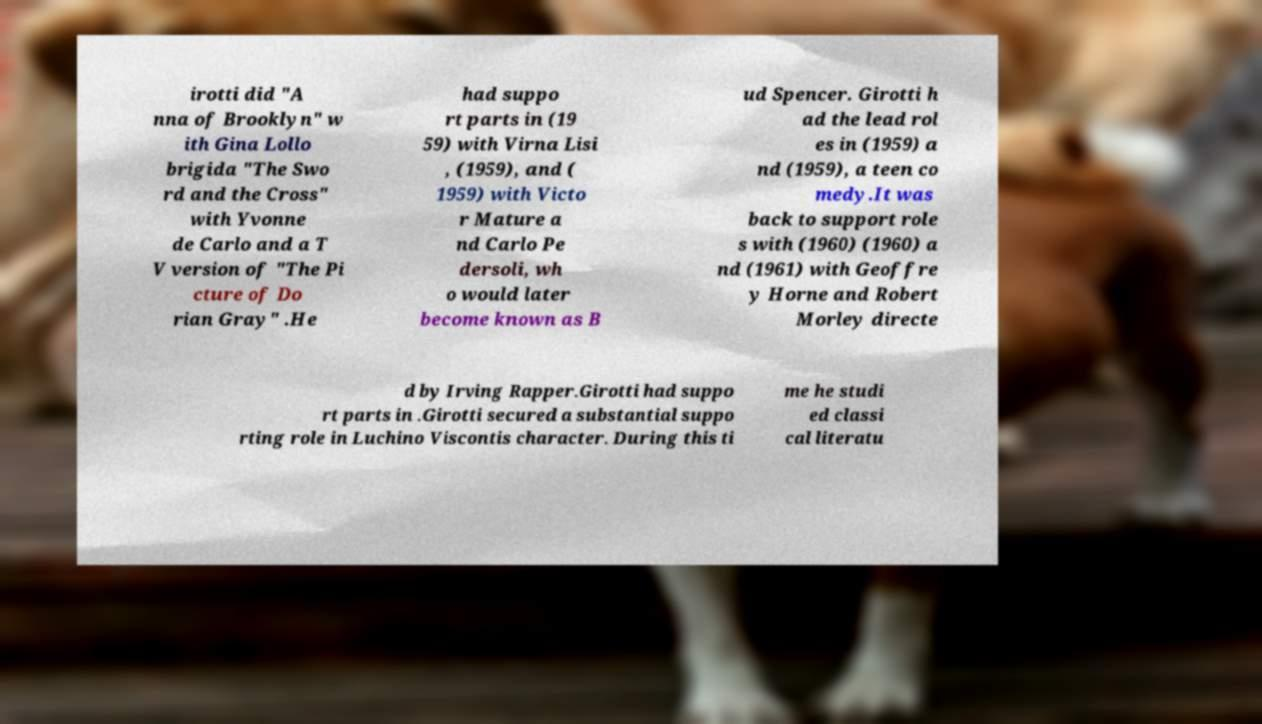Could you assist in decoding the text presented in this image and type it out clearly? irotti did "A nna of Brooklyn" w ith Gina Lollo brigida "The Swo rd and the Cross" with Yvonne de Carlo and a T V version of "The Pi cture of Do rian Gray" .He had suppo rt parts in (19 59) with Virna Lisi , (1959), and ( 1959) with Victo r Mature a nd Carlo Pe dersoli, wh o would later become known as B ud Spencer. Girotti h ad the lead rol es in (1959) a nd (1959), a teen co medy.It was back to support role s with (1960) (1960) a nd (1961) with Geoffre y Horne and Robert Morley directe d by Irving Rapper.Girotti had suppo rt parts in .Girotti secured a substantial suppo rting role in Luchino Viscontis character. During this ti me he studi ed classi cal literatu 